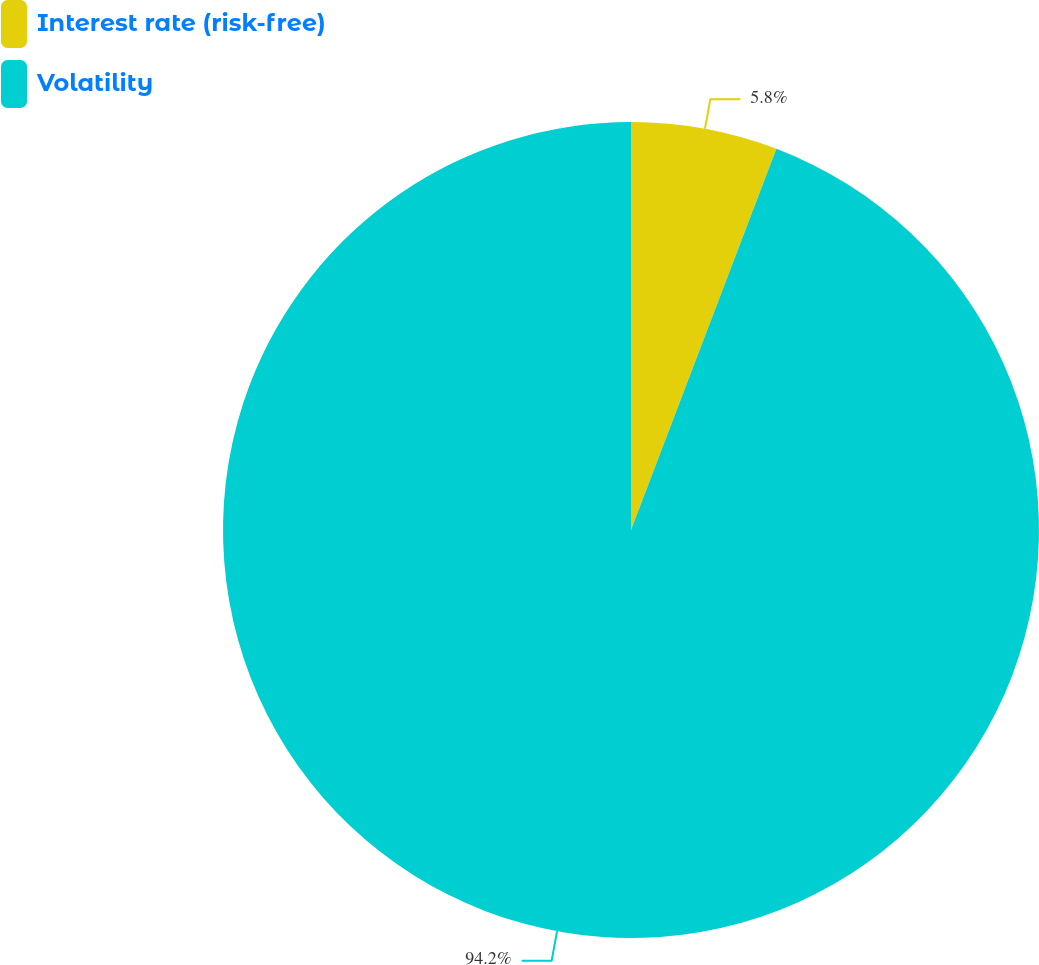Convert chart. <chart><loc_0><loc_0><loc_500><loc_500><pie_chart><fcel>Interest rate (risk-free)<fcel>Volatility<nl><fcel>5.8%<fcel>94.2%<nl></chart> 